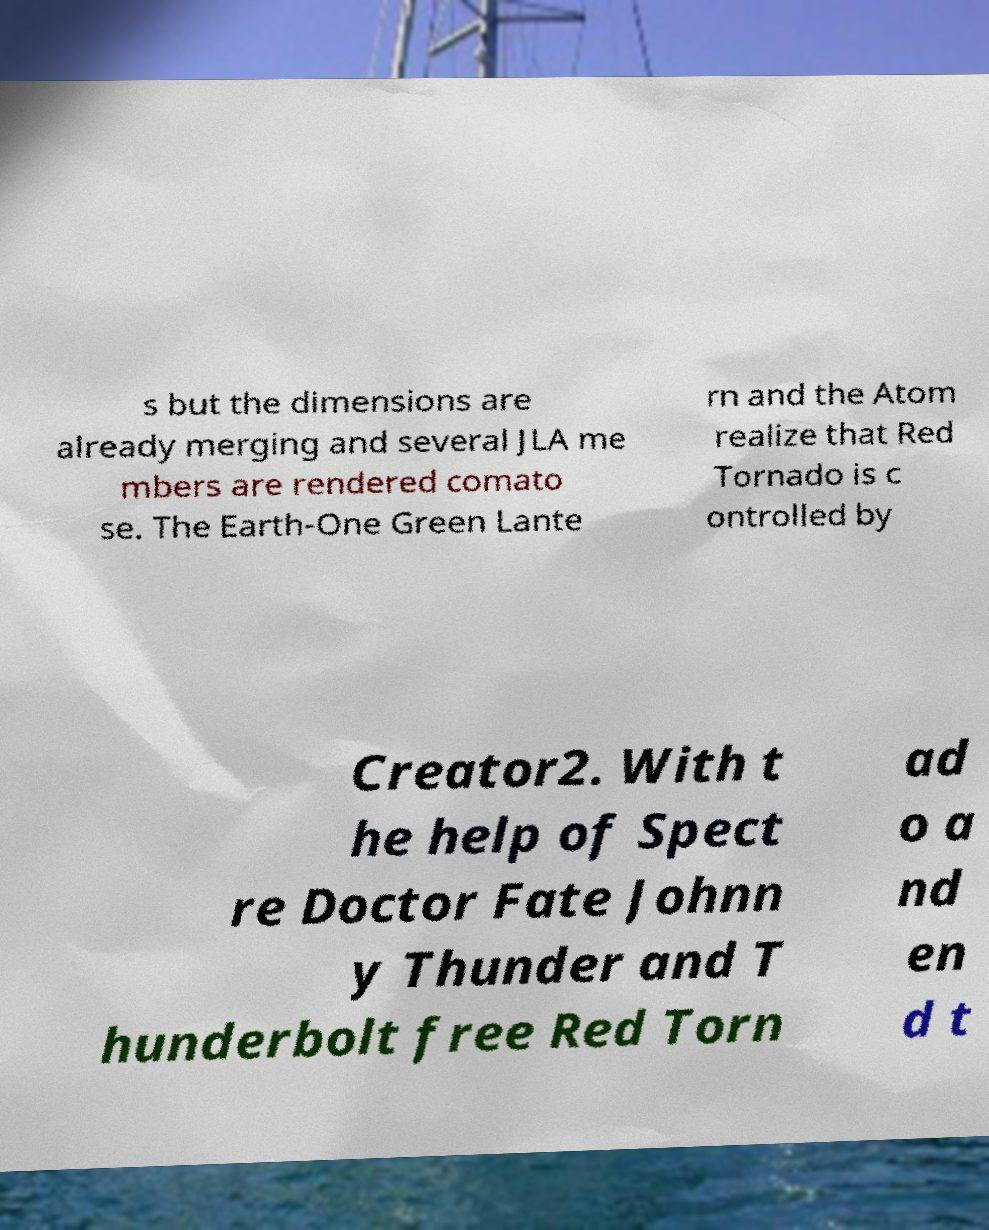Please identify and transcribe the text found in this image. s but the dimensions are already merging and several JLA me mbers are rendered comato se. The Earth-One Green Lante rn and the Atom realize that Red Tornado is c ontrolled by Creator2. With t he help of Spect re Doctor Fate Johnn y Thunder and T hunderbolt free Red Torn ad o a nd en d t 